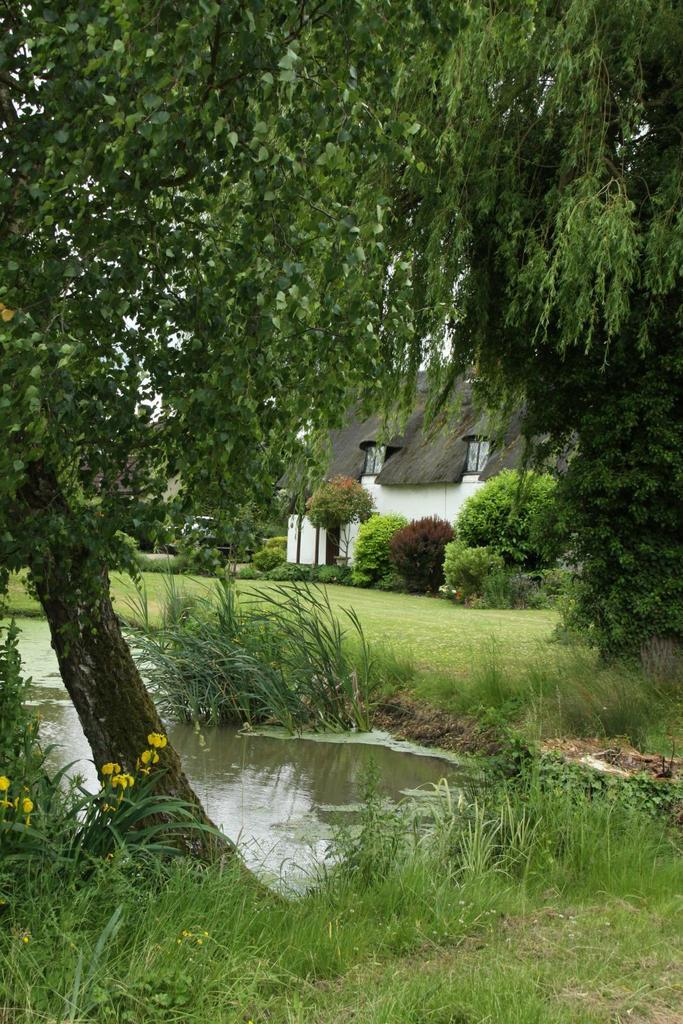What type of terrain is visible in the image? There is an open ground in the image. What type of vegetation is present in the image? Grass and trees are visible in the image. Where is the water located in the image? The water is visible on the left side of the image. What can be seen in the background of the image? There is a building in the background of the image. What type of goose is present in the image? There is no goose present in the image. What facial expression can be seen on the trees in the image? Trees do not have facial expressions, so this cannot be determined from the image. 